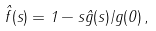Convert formula to latex. <formula><loc_0><loc_0><loc_500><loc_500>\hat { f } ( s ) = 1 - s \hat { g } ( s ) / g ( 0 ) \, ,</formula> 